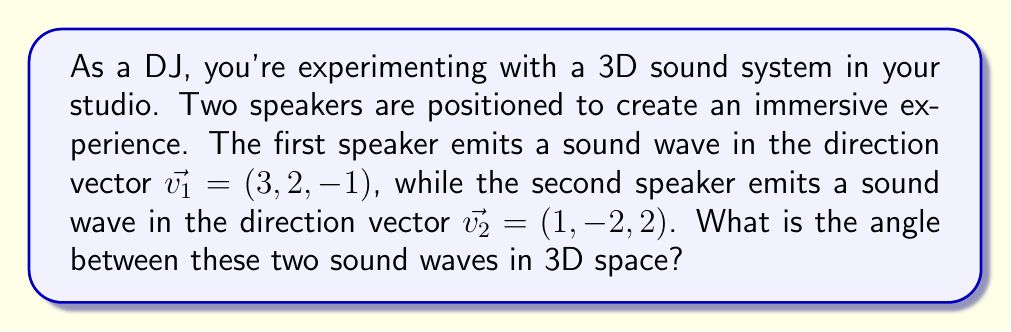Provide a solution to this math problem. To find the angle between two vectors in 3D space, we can use the dot product formula:

$$\cos \theta = \frac{\vec{v_1} \cdot \vec{v_2}}{|\vec{v_1}| |\vec{v_2}|}$$

Where $\theta$ is the angle between the vectors, $\vec{v_1} \cdot \vec{v_2}$ is the dot product of the vectors, and $|\vec{v_1}|$ and $|\vec{v_2}|$ are the magnitudes of the vectors.

Step 1: Calculate the dot product $\vec{v_1} \cdot \vec{v_2}$
$$\vec{v_1} \cdot \vec{v_2} = (3)(1) + (2)(-2) + (-1)(2) = 3 - 4 - 2 = -3$$

Step 2: Calculate the magnitudes of the vectors
$$|\vec{v_1}| = \sqrt{3^2 + 2^2 + (-1)^2} = \sqrt{14}$$
$$|\vec{v_2}| = \sqrt{1^2 + (-2)^2 + 2^2} = 3$$

Step 3: Substitute into the dot product formula
$$\cos \theta = \frac{-3}{\sqrt{14} \cdot 3}$$

Step 4: Solve for $\theta$ using the inverse cosine function
$$\theta = \arccos\left(\frac{-3}{\sqrt{14} \cdot 3}\right)$$

Step 5: Calculate the final result
$$\theta \approx 2.0344 \text{ radians}$$

Convert to degrees:
$$\theta \approx 2.0344 \cdot \frac{180}{\pi} \approx 116.57°$$
Answer: The angle between the two sound waves is approximately 116.57°. 